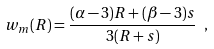<formula> <loc_0><loc_0><loc_500><loc_500>w _ { m } ( R ) = \frac { ( \alpha - 3 ) R + ( \beta - 3 ) s } { 3 ( R + s ) } \ ,</formula> 